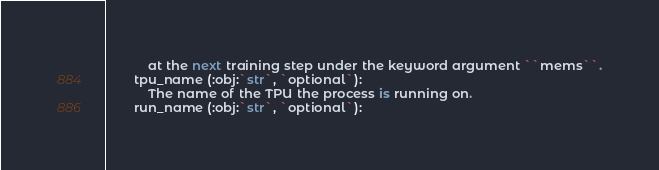<code> <loc_0><loc_0><loc_500><loc_500><_Python_>            at the next training step under the keyword argument ``mems``.
        tpu_name (:obj:`str`, `optional`):
            The name of the TPU the process is running on.
        run_name (:obj:`str`, `optional`):</code> 